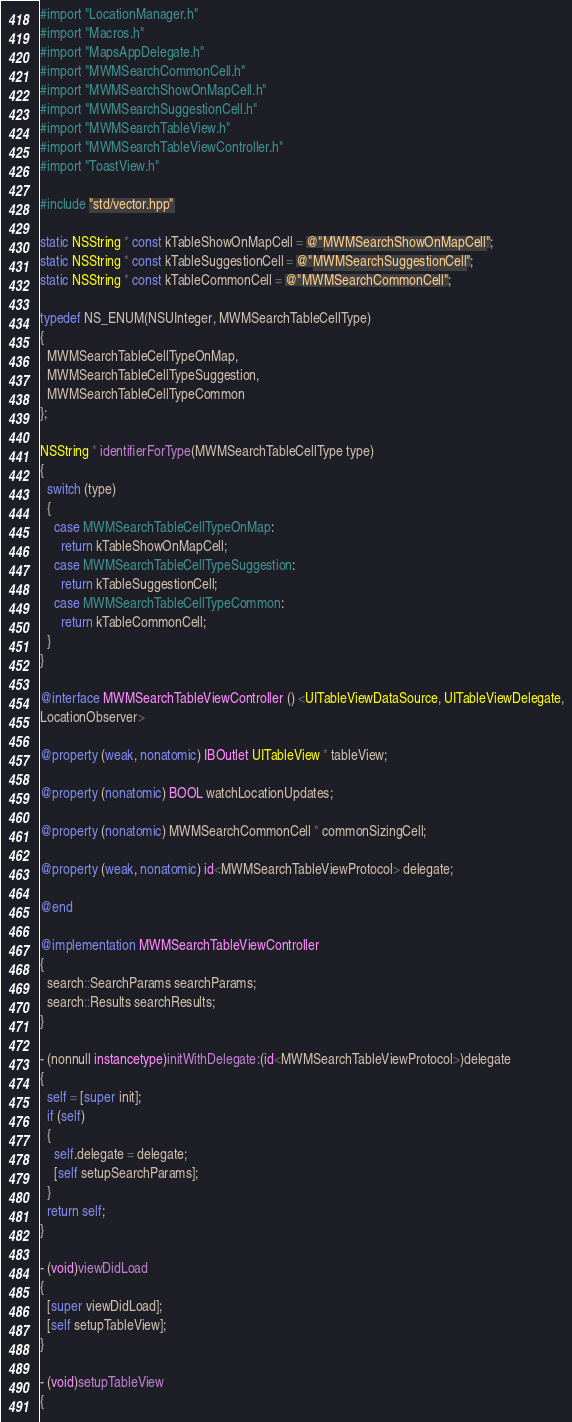Convert code to text. <code><loc_0><loc_0><loc_500><loc_500><_ObjectiveC_>#import "LocationManager.h"
#import "Macros.h"
#import "MapsAppDelegate.h"
#import "MWMSearchCommonCell.h"
#import "MWMSearchShowOnMapCell.h"
#import "MWMSearchSuggestionCell.h"
#import "MWMSearchTableView.h"
#import "MWMSearchTableViewController.h"
#import "ToastView.h"

#include "std/vector.hpp"

static NSString * const kTableShowOnMapCell = @"MWMSearchShowOnMapCell";
static NSString * const kTableSuggestionCell = @"MWMSearchSuggestionCell";
static NSString * const kTableCommonCell = @"MWMSearchCommonCell";

typedef NS_ENUM(NSUInteger, MWMSearchTableCellType)
{
  MWMSearchTableCellTypeOnMap,
  MWMSearchTableCellTypeSuggestion,
  MWMSearchTableCellTypeCommon
};

NSString * identifierForType(MWMSearchTableCellType type)
{
  switch (type)
  {
    case MWMSearchTableCellTypeOnMap:
      return kTableShowOnMapCell;
    case MWMSearchTableCellTypeSuggestion:
      return kTableSuggestionCell;
    case MWMSearchTableCellTypeCommon:
      return kTableCommonCell;
  }
}

@interface MWMSearchTableViewController () <UITableViewDataSource, UITableViewDelegate,
LocationObserver>

@property (weak, nonatomic) IBOutlet UITableView * tableView;

@property (nonatomic) BOOL watchLocationUpdates;

@property (nonatomic) MWMSearchCommonCell * commonSizingCell;

@property (weak, nonatomic) id<MWMSearchTableViewProtocol> delegate;

@end

@implementation MWMSearchTableViewController
{
  search::SearchParams searchParams;
  search::Results searchResults;
}

- (nonnull instancetype)initWithDelegate:(id<MWMSearchTableViewProtocol>)delegate
{
  self = [super init];
  if (self)
  {
    self.delegate = delegate;
    [self setupSearchParams];
  }
  return self;
}

- (void)viewDidLoad
{
  [super viewDidLoad];
  [self setupTableView];
}

- (void)setupTableView
{</code> 